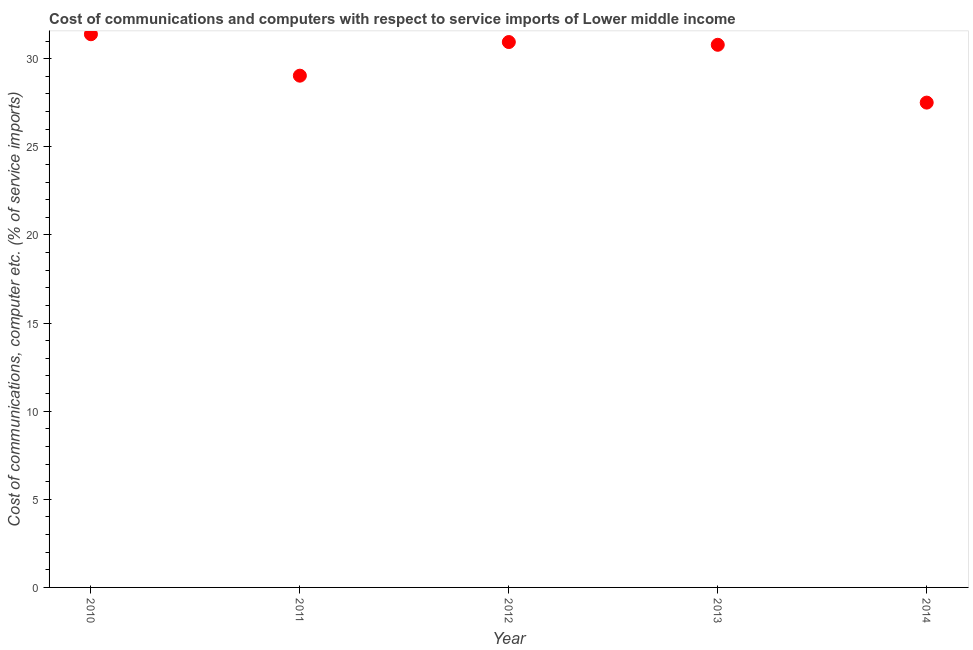What is the cost of communications and computer in 2010?
Offer a very short reply. 31.38. Across all years, what is the maximum cost of communications and computer?
Offer a terse response. 31.38. Across all years, what is the minimum cost of communications and computer?
Your answer should be very brief. 27.51. What is the sum of the cost of communications and computer?
Ensure brevity in your answer.  149.65. What is the difference between the cost of communications and computer in 2011 and 2013?
Make the answer very short. -1.75. What is the average cost of communications and computer per year?
Offer a terse response. 29.93. What is the median cost of communications and computer?
Ensure brevity in your answer.  30.79. In how many years, is the cost of communications and computer greater than 12 %?
Offer a very short reply. 5. What is the ratio of the cost of communications and computer in 2011 to that in 2014?
Your answer should be compact. 1.06. Is the cost of communications and computer in 2012 less than that in 2014?
Offer a terse response. No. What is the difference between the highest and the second highest cost of communications and computer?
Provide a succinct answer. 0.44. What is the difference between the highest and the lowest cost of communications and computer?
Give a very brief answer. 3.88. In how many years, is the cost of communications and computer greater than the average cost of communications and computer taken over all years?
Your response must be concise. 3. Does the cost of communications and computer monotonically increase over the years?
Provide a succinct answer. No. How many dotlines are there?
Offer a terse response. 1. Does the graph contain any zero values?
Offer a very short reply. No. What is the title of the graph?
Your answer should be very brief. Cost of communications and computers with respect to service imports of Lower middle income. What is the label or title of the X-axis?
Offer a terse response. Year. What is the label or title of the Y-axis?
Your answer should be compact. Cost of communications, computer etc. (% of service imports). What is the Cost of communications, computer etc. (% of service imports) in 2010?
Provide a short and direct response. 31.38. What is the Cost of communications, computer etc. (% of service imports) in 2011?
Ensure brevity in your answer.  29.03. What is the Cost of communications, computer etc. (% of service imports) in 2012?
Keep it short and to the point. 30.94. What is the Cost of communications, computer etc. (% of service imports) in 2013?
Offer a terse response. 30.79. What is the Cost of communications, computer etc. (% of service imports) in 2014?
Provide a short and direct response. 27.51. What is the difference between the Cost of communications, computer etc. (% of service imports) in 2010 and 2011?
Offer a terse response. 2.35. What is the difference between the Cost of communications, computer etc. (% of service imports) in 2010 and 2012?
Ensure brevity in your answer.  0.44. What is the difference between the Cost of communications, computer etc. (% of service imports) in 2010 and 2013?
Provide a short and direct response. 0.6. What is the difference between the Cost of communications, computer etc. (% of service imports) in 2010 and 2014?
Your response must be concise. 3.88. What is the difference between the Cost of communications, computer etc. (% of service imports) in 2011 and 2012?
Your answer should be compact. -1.91. What is the difference between the Cost of communications, computer etc. (% of service imports) in 2011 and 2013?
Provide a succinct answer. -1.75. What is the difference between the Cost of communications, computer etc. (% of service imports) in 2011 and 2014?
Ensure brevity in your answer.  1.53. What is the difference between the Cost of communications, computer etc. (% of service imports) in 2012 and 2013?
Offer a terse response. 0.16. What is the difference between the Cost of communications, computer etc. (% of service imports) in 2012 and 2014?
Provide a short and direct response. 3.44. What is the difference between the Cost of communications, computer etc. (% of service imports) in 2013 and 2014?
Keep it short and to the point. 3.28. What is the ratio of the Cost of communications, computer etc. (% of service imports) in 2010 to that in 2011?
Give a very brief answer. 1.08. What is the ratio of the Cost of communications, computer etc. (% of service imports) in 2010 to that in 2014?
Provide a succinct answer. 1.14. What is the ratio of the Cost of communications, computer etc. (% of service imports) in 2011 to that in 2012?
Offer a very short reply. 0.94. What is the ratio of the Cost of communications, computer etc. (% of service imports) in 2011 to that in 2013?
Offer a terse response. 0.94. What is the ratio of the Cost of communications, computer etc. (% of service imports) in 2011 to that in 2014?
Your answer should be compact. 1.06. What is the ratio of the Cost of communications, computer etc. (% of service imports) in 2012 to that in 2013?
Keep it short and to the point. 1. What is the ratio of the Cost of communications, computer etc. (% of service imports) in 2012 to that in 2014?
Offer a terse response. 1.12. What is the ratio of the Cost of communications, computer etc. (% of service imports) in 2013 to that in 2014?
Ensure brevity in your answer.  1.12. 